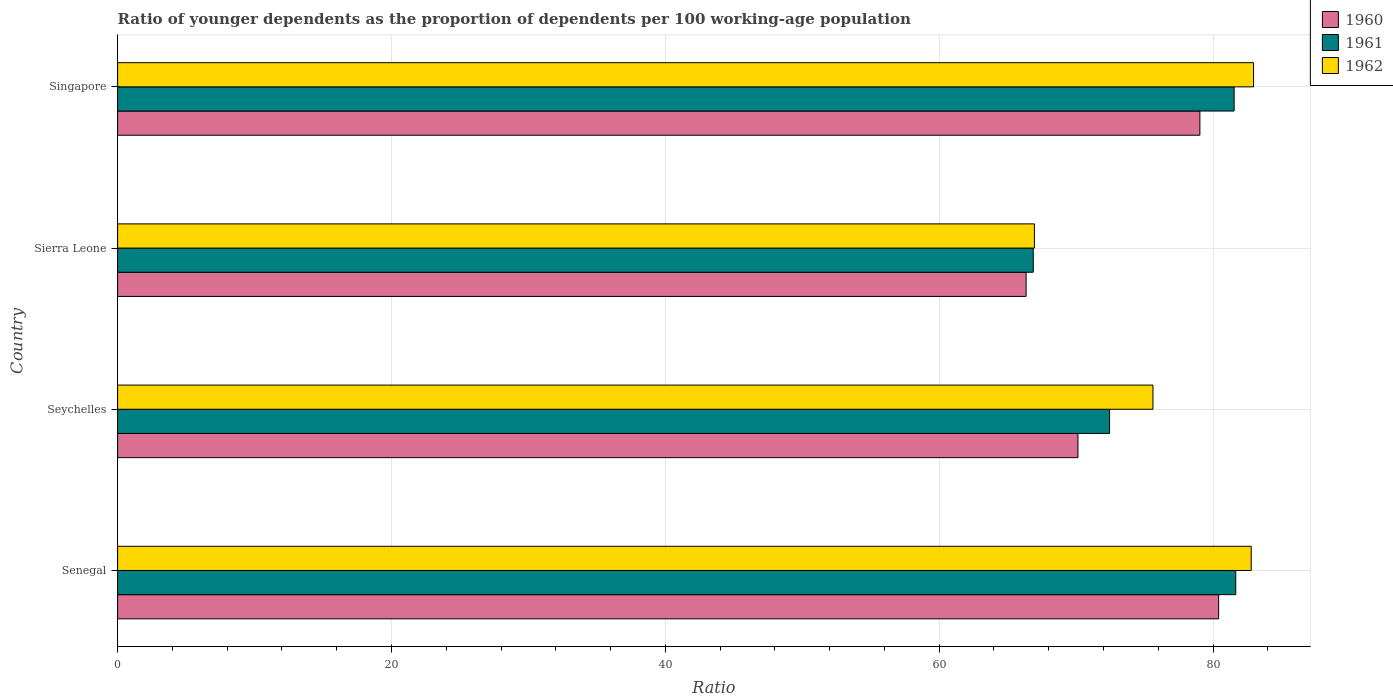How many different coloured bars are there?
Provide a succinct answer. 3. How many groups of bars are there?
Your answer should be compact. 4. Are the number of bars on each tick of the Y-axis equal?
Offer a terse response. Yes. What is the label of the 1st group of bars from the top?
Keep it short and to the point. Singapore. In how many cases, is the number of bars for a given country not equal to the number of legend labels?
Provide a succinct answer. 0. What is the age dependency ratio(young) in 1962 in Seychelles?
Provide a succinct answer. 75.62. Across all countries, what is the maximum age dependency ratio(young) in 1962?
Your answer should be very brief. 82.96. Across all countries, what is the minimum age dependency ratio(young) in 1962?
Keep it short and to the point. 66.96. In which country was the age dependency ratio(young) in 1962 maximum?
Provide a short and direct response. Singapore. In which country was the age dependency ratio(young) in 1960 minimum?
Provide a succinct answer. Sierra Leone. What is the total age dependency ratio(young) in 1962 in the graph?
Offer a very short reply. 308.33. What is the difference between the age dependency ratio(young) in 1962 in Senegal and that in Seychelles?
Offer a very short reply. 7.18. What is the difference between the age dependency ratio(young) in 1962 in Seychelles and the age dependency ratio(young) in 1960 in Senegal?
Offer a terse response. -4.8. What is the average age dependency ratio(young) in 1962 per country?
Your response must be concise. 77.08. What is the difference between the age dependency ratio(young) in 1962 and age dependency ratio(young) in 1961 in Sierra Leone?
Provide a short and direct response. 0.09. What is the ratio of the age dependency ratio(young) in 1962 in Seychelles to that in Singapore?
Give a very brief answer. 0.91. Is the difference between the age dependency ratio(young) in 1962 in Senegal and Seychelles greater than the difference between the age dependency ratio(young) in 1961 in Senegal and Seychelles?
Make the answer very short. No. What is the difference between the highest and the second highest age dependency ratio(young) in 1961?
Your answer should be compact. 0.12. What is the difference between the highest and the lowest age dependency ratio(young) in 1962?
Your answer should be very brief. 16.01. In how many countries, is the age dependency ratio(young) in 1961 greater than the average age dependency ratio(young) in 1961 taken over all countries?
Give a very brief answer. 2. How many bars are there?
Your answer should be compact. 12. Are all the bars in the graph horizontal?
Ensure brevity in your answer.  Yes. What is the difference between two consecutive major ticks on the X-axis?
Make the answer very short. 20. How are the legend labels stacked?
Give a very brief answer. Vertical. What is the title of the graph?
Your answer should be compact. Ratio of younger dependents as the proportion of dependents per 100 working-age population. What is the label or title of the X-axis?
Provide a succinct answer. Ratio. What is the Ratio of 1960 in Senegal?
Offer a terse response. 80.41. What is the Ratio of 1961 in Senegal?
Provide a short and direct response. 81.66. What is the Ratio of 1962 in Senegal?
Make the answer very short. 82.79. What is the Ratio in 1960 in Seychelles?
Offer a terse response. 70.14. What is the Ratio in 1961 in Seychelles?
Give a very brief answer. 72.45. What is the Ratio in 1962 in Seychelles?
Give a very brief answer. 75.62. What is the Ratio of 1960 in Sierra Leone?
Provide a succinct answer. 66.35. What is the Ratio of 1961 in Sierra Leone?
Your answer should be very brief. 66.87. What is the Ratio of 1962 in Sierra Leone?
Offer a very short reply. 66.96. What is the Ratio in 1960 in Singapore?
Keep it short and to the point. 79.04. What is the Ratio of 1961 in Singapore?
Your response must be concise. 81.54. What is the Ratio of 1962 in Singapore?
Give a very brief answer. 82.96. Across all countries, what is the maximum Ratio in 1960?
Make the answer very short. 80.41. Across all countries, what is the maximum Ratio of 1961?
Your response must be concise. 81.66. Across all countries, what is the maximum Ratio in 1962?
Offer a terse response. 82.96. Across all countries, what is the minimum Ratio of 1960?
Make the answer very short. 66.35. Across all countries, what is the minimum Ratio in 1961?
Your answer should be very brief. 66.87. Across all countries, what is the minimum Ratio of 1962?
Ensure brevity in your answer.  66.96. What is the total Ratio in 1960 in the graph?
Offer a very short reply. 295.94. What is the total Ratio of 1961 in the graph?
Provide a short and direct response. 302.53. What is the total Ratio in 1962 in the graph?
Provide a short and direct response. 308.33. What is the difference between the Ratio of 1960 in Senegal and that in Seychelles?
Provide a succinct answer. 10.27. What is the difference between the Ratio of 1961 in Senegal and that in Seychelles?
Keep it short and to the point. 9.21. What is the difference between the Ratio in 1962 in Senegal and that in Seychelles?
Offer a terse response. 7.18. What is the difference between the Ratio in 1960 in Senegal and that in Sierra Leone?
Your answer should be compact. 14.06. What is the difference between the Ratio in 1961 in Senegal and that in Sierra Leone?
Your answer should be very brief. 14.79. What is the difference between the Ratio in 1962 in Senegal and that in Sierra Leone?
Provide a short and direct response. 15.83. What is the difference between the Ratio of 1960 in Senegal and that in Singapore?
Keep it short and to the point. 1.37. What is the difference between the Ratio of 1961 in Senegal and that in Singapore?
Provide a succinct answer. 0.12. What is the difference between the Ratio in 1962 in Senegal and that in Singapore?
Offer a very short reply. -0.17. What is the difference between the Ratio of 1960 in Seychelles and that in Sierra Leone?
Make the answer very short. 3.79. What is the difference between the Ratio of 1961 in Seychelles and that in Sierra Leone?
Offer a terse response. 5.58. What is the difference between the Ratio in 1962 in Seychelles and that in Sierra Leone?
Your answer should be compact. 8.66. What is the difference between the Ratio of 1960 in Seychelles and that in Singapore?
Provide a short and direct response. -8.9. What is the difference between the Ratio in 1961 in Seychelles and that in Singapore?
Offer a very short reply. -9.1. What is the difference between the Ratio of 1962 in Seychelles and that in Singapore?
Your answer should be very brief. -7.35. What is the difference between the Ratio of 1960 in Sierra Leone and that in Singapore?
Offer a terse response. -12.69. What is the difference between the Ratio in 1961 in Sierra Leone and that in Singapore?
Provide a succinct answer. -14.67. What is the difference between the Ratio in 1962 in Sierra Leone and that in Singapore?
Provide a short and direct response. -16.01. What is the difference between the Ratio in 1960 in Senegal and the Ratio in 1961 in Seychelles?
Give a very brief answer. 7.96. What is the difference between the Ratio of 1960 in Senegal and the Ratio of 1962 in Seychelles?
Give a very brief answer. 4.8. What is the difference between the Ratio of 1961 in Senegal and the Ratio of 1962 in Seychelles?
Provide a short and direct response. 6.05. What is the difference between the Ratio in 1960 in Senegal and the Ratio in 1961 in Sierra Leone?
Ensure brevity in your answer.  13.54. What is the difference between the Ratio of 1960 in Senegal and the Ratio of 1962 in Sierra Leone?
Offer a terse response. 13.45. What is the difference between the Ratio in 1961 in Senegal and the Ratio in 1962 in Sierra Leone?
Your answer should be very brief. 14.7. What is the difference between the Ratio of 1960 in Senegal and the Ratio of 1961 in Singapore?
Make the answer very short. -1.13. What is the difference between the Ratio in 1960 in Senegal and the Ratio in 1962 in Singapore?
Provide a succinct answer. -2.55. What is the difference between the Ratio in 1961 in Senegal and the Ratio in 1962 in Singapore?
Your answer should be compact. -1.3. What is the difference between the Ratio of 1960 in Seychelles and the Ratio of 1961 in Sierra Leone?
Ensure brevity in your answer.  3.27. What is the difference between the Ratio of 1960 in Seychelles and the Ratio of 1962 in Sierra Leone?
Your response must be concise. 3.18. What is the difference between the Ratio in 1961 in Seychelles and the Ratio in 1962 in Sierra Leone?
Your answer should be compact. 5.49. What is the difference between the Ratio of 1960 in Seychelles and the Ratio of 1961 in Singapore?
Your answer should be compact. -11.41. What is the difference between the Ratio in 1960 in Seychelles and the Ratio in 1962 in Singapore?
Provide a succinct answer. -12.83. What is the difference between the Ratio in 1961 in Seychelles and the Ratio in 1962 in Singapore?
Your response must be concise. -10.51. What is the difference between the Ratio of 1960 in Sierra Leone and the Ratio of 1961 in Singapore?
Offer a terse response. -15.19. What is the difference between the Ratio of 1960 in Sierra Leone and the Ratio of 1962 in Singapore?
Provide a short and direct response. -16.61. What is the difference between the Ratio in 1961 in Sierra Leone and the Ratio in 1962 in Singapore?
Your answer should be very brief. -16.09. What is the average Ratio of 1960 per country?
Your answer should be very brief. 73.99. What is the average Ratio in 1961 per country?
Give a very brief answer. 75.63. What is the average Ratio of 1962 per country?
Keep it short and to the point. 77.08. What is the difference between the Ratio of 1960 and Ratio of 1961 in Senegal?
Ensure brevity in your answer.  -1.25. What is the difference between the Ratio in 1960 and Ratio in 1962 in Senegal?
Provide a succinct answer. -2.38. What is the difference between the Ratio of 1961 and Ratio of 1962 in Senegal?
Your answer should be very brief. -1.13. What is the difference between the Ratio of 1960 and Ratio of 1961 in Seychelles?
Give a very brief answer. -2.31. What is the difference between the Ratio of 1960 and Ratio of 1962 in Seychelles?
Offer a terse response. -5.48. What is the difference between the Ratio of 1961 and Ratio of 1962 in Seychelles?
Your response must be concise. -3.17. What is the difference between the Ratio of 1960 and Ratio of 1961 in Sierra Leone?
Provide a short and direct response. -0.52. What is the difference between the Ratio in 1960 and Ratio in 1962 in Sierra Leone?
Keep it short and to the point. -0.61. What is the difference between the Ratio in 1961 and Ratio in 1962 in Sierra Leone?
Offer a very short reply. -0.09. What is the difference between the Ratio in 1960 and Ratio in 1961 in Singapore?
Ensure brevity in your answer.  -2.5. What is the difference between the Ratio of 1960 and Ratio of 1962 in Singapore?
Give a very brief answer. -3.92. What is the difference between the Ratio of 1961 and Ratio of 1962 in Singapore?
Provide a succinct answer. -1.42. What is the ratio of the Ratio of 1960 in Senegal to that in Seychelles?
Your answer should be compact. 1.15. What is the ratio of the Ratio in 1961 in Senegal to that in Seychelles?
Make the answer very short. 1.13. What is the ratio of the Ratio in 1962 in Senegal to that in Seychelles?
Ensure brevity in your answer.  1.09. What is the ratio of the Ratio in 1960 in Senegal to that in Sierra Leone?
Offer a terse response. 1.21. What is the ratio of the Ratio of 1961 in Senegal to that in Sierra Leone?
Provide a succinct answer. 1.22. What is the ratio of the Ratio in 1962 in Senegal to that in Sierra Leone?
Provide a succinct answer. 1.24. What is the ratio of the Ratio of 1960 in Senegal to that in Singapore?
Your response must be concise. 1.02. What is the ratio of the Ratio of 1962 in Senegal to that in Singapore?
Make the answer very short. 1. What is the ratio of the Ratio of 1960 in Seychelles to that in Sierra Leone?
Ensure brevity in your answer.  1.06. What is the ratio of the Ratio of 1961 in Seychelles to that in Sierra Leone?
Give a very brief answer. 1.08. What is the ratio of the Ratio of 1962 in Seychelles to that in Sierra Leone?
Ensure brevity in your answer.  1.13. What is the ratio of the Ratio of 1960 in Seychelles to that in Singapore?
Your response must be concise. 0.89. What is the ratio of the Ratio in 1961 in Seychelles to that in Singapore?
Keep it short and to the point. 0.89. What is the ratio of the Ratio in 1962 in Seychelles to that in Singapore?
Provide a succinct answer. 0.91. What is the ratio of the Ratio of 1960 in Sierra Leone to that in Singapore?
Give a very brief answer. 0.84. What is the ratio of the Ratio in 1961 in Sierra Leone to that in Singapore?
Make the answer very short. 0.82. What is the ratio of the Ratio in 1962 in Sierra Leone to that in Singapore?
Give a very brief answer. 0.81. What is the difference between the highest and the second highest Ratio in 1960?
Ensure brevity in your answer.  1.37. What is the difference between the highest and the second highest Ratio of 1961?
Ensure brevity in your answer.  0.12. What is the difference between the highest and the second highest Ratio of 1962?
Make the answer very short. 0.17. What is the difference between the highest and the lowest Ratio in 1960?
Keep it short and to the point. 14.06. What is the difference between the highest and the lowest Ratio of 1961?
Offer a very short reply. 14.79. What is the difference between the highest and the lowest Ratio in 1962?
Your response must be concise. 16.01. 